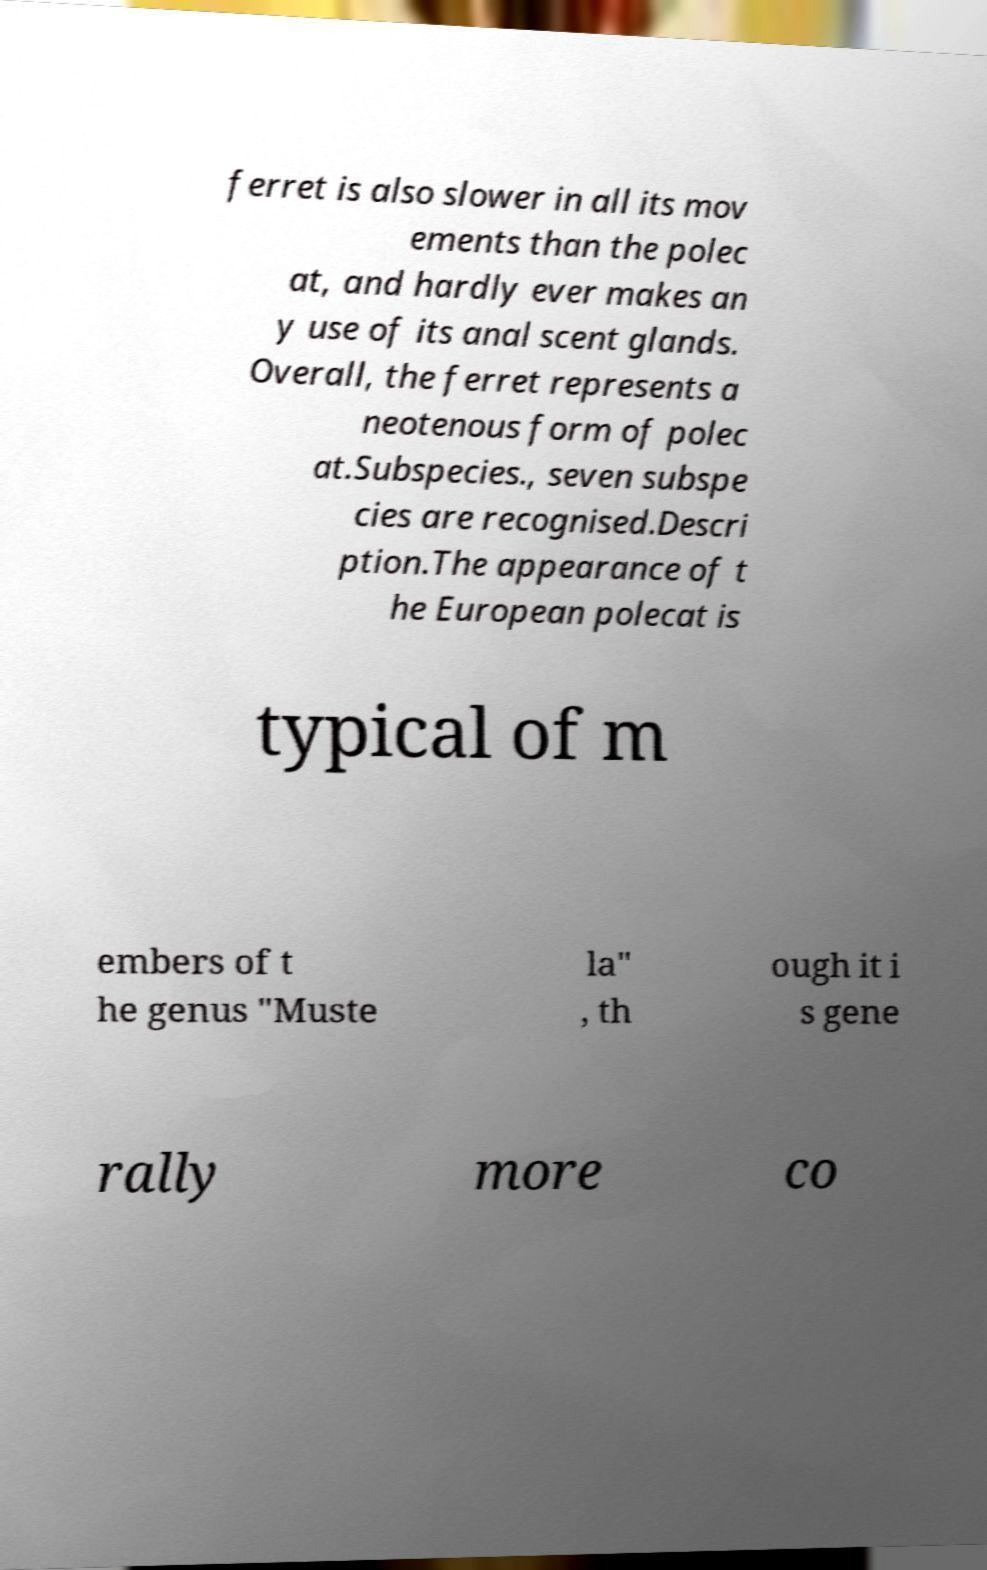Could you assist in decoding the text presented in this image and type it out clearly? ferret is also slower in all its mov ements than the polec at, and hardly ever makes an y use of its anal scent glands. Overall, the ferret represents a neotenous form of polec at.Subspecies., seven subspe cies are recognised.Descri ption.The appearance of t he European polecat is typical of m embers of t he genus "Muste la" , th ough it i s gene rally more co 